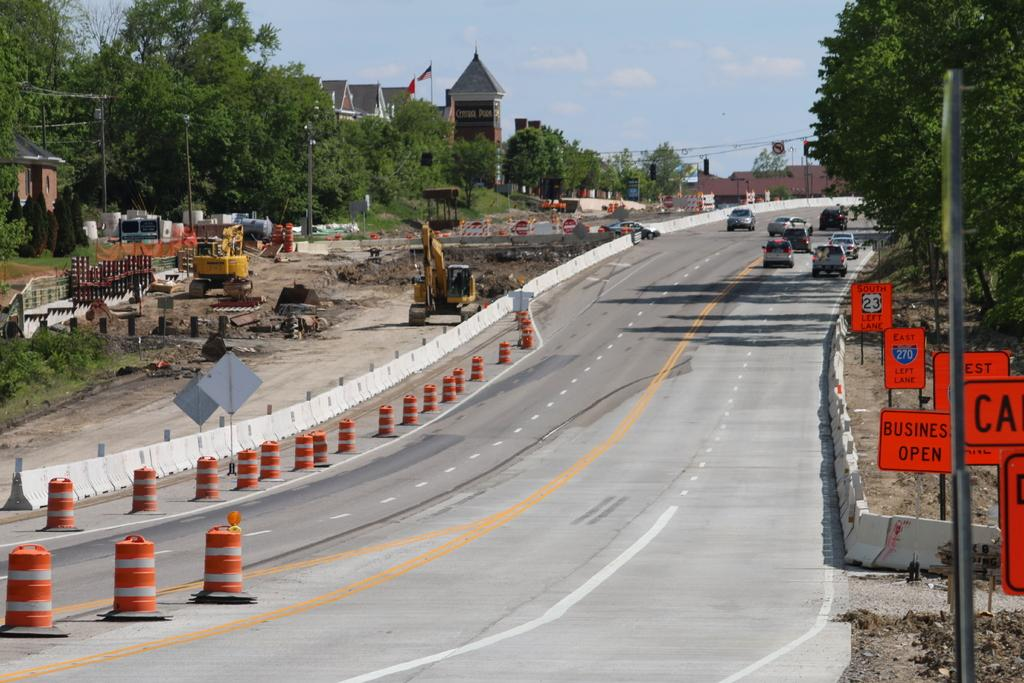<image>
Write a terse but informative summary of the picture. Empty road with an orange sign which says Business Open. 